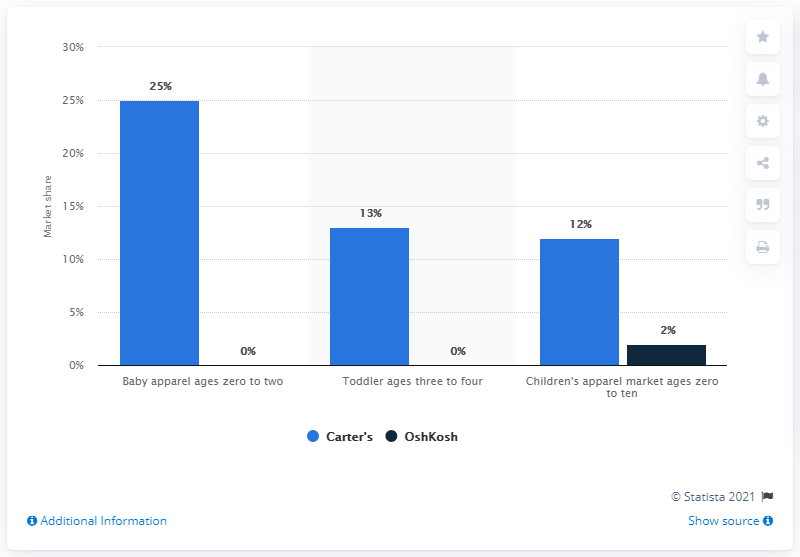How does Carter's market share in baby apparel compare to its market share in the children's apparel for ages zero to ten? In the image, Carter's market share for baby apparel ages zero to two stands at 25%, while its market share for children's apparel ages zero to ten is only 12%. This indicates that Carter's has a notably higher presence in the baby apparel market compared to its broader market for children's apparel in the specified age range. 